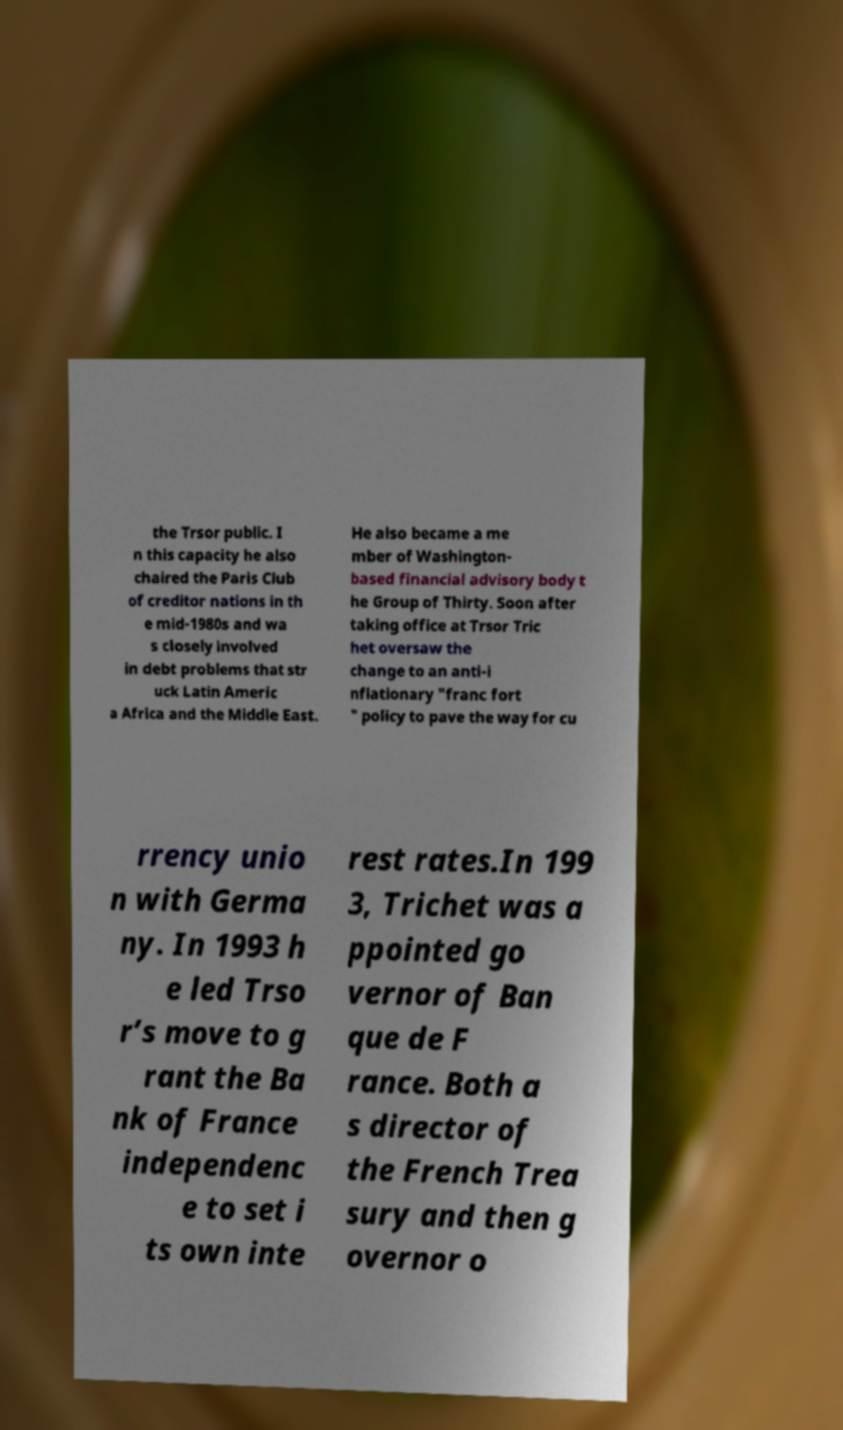What messages or text are displayed in this image? I need them in a readable, typed format. the Trsor public. I n this capacity he also chaired the Paris Club of creditor nations in th e mid-1980s and wa s closely involved in debt problems that str uck Latin Americ a Africa and the Middle East. He also became a me mber of Washington- based financial advisory body t he Group of Thirty. Soon after taking office at Trsor Tric het oversaw the change to an anti-i nflationary "franc fort " policy to pave the way for cu rrency unio n with Germa ny. In 1993 h e led Trso r’s move to g rant the Ba nk of France independenc e to set i ts own inte rest rates.In 199 3, Trichet was a ppointed go vernor of Ban que de F rance. Both a s director of the French Trea sury and then g overnor o 